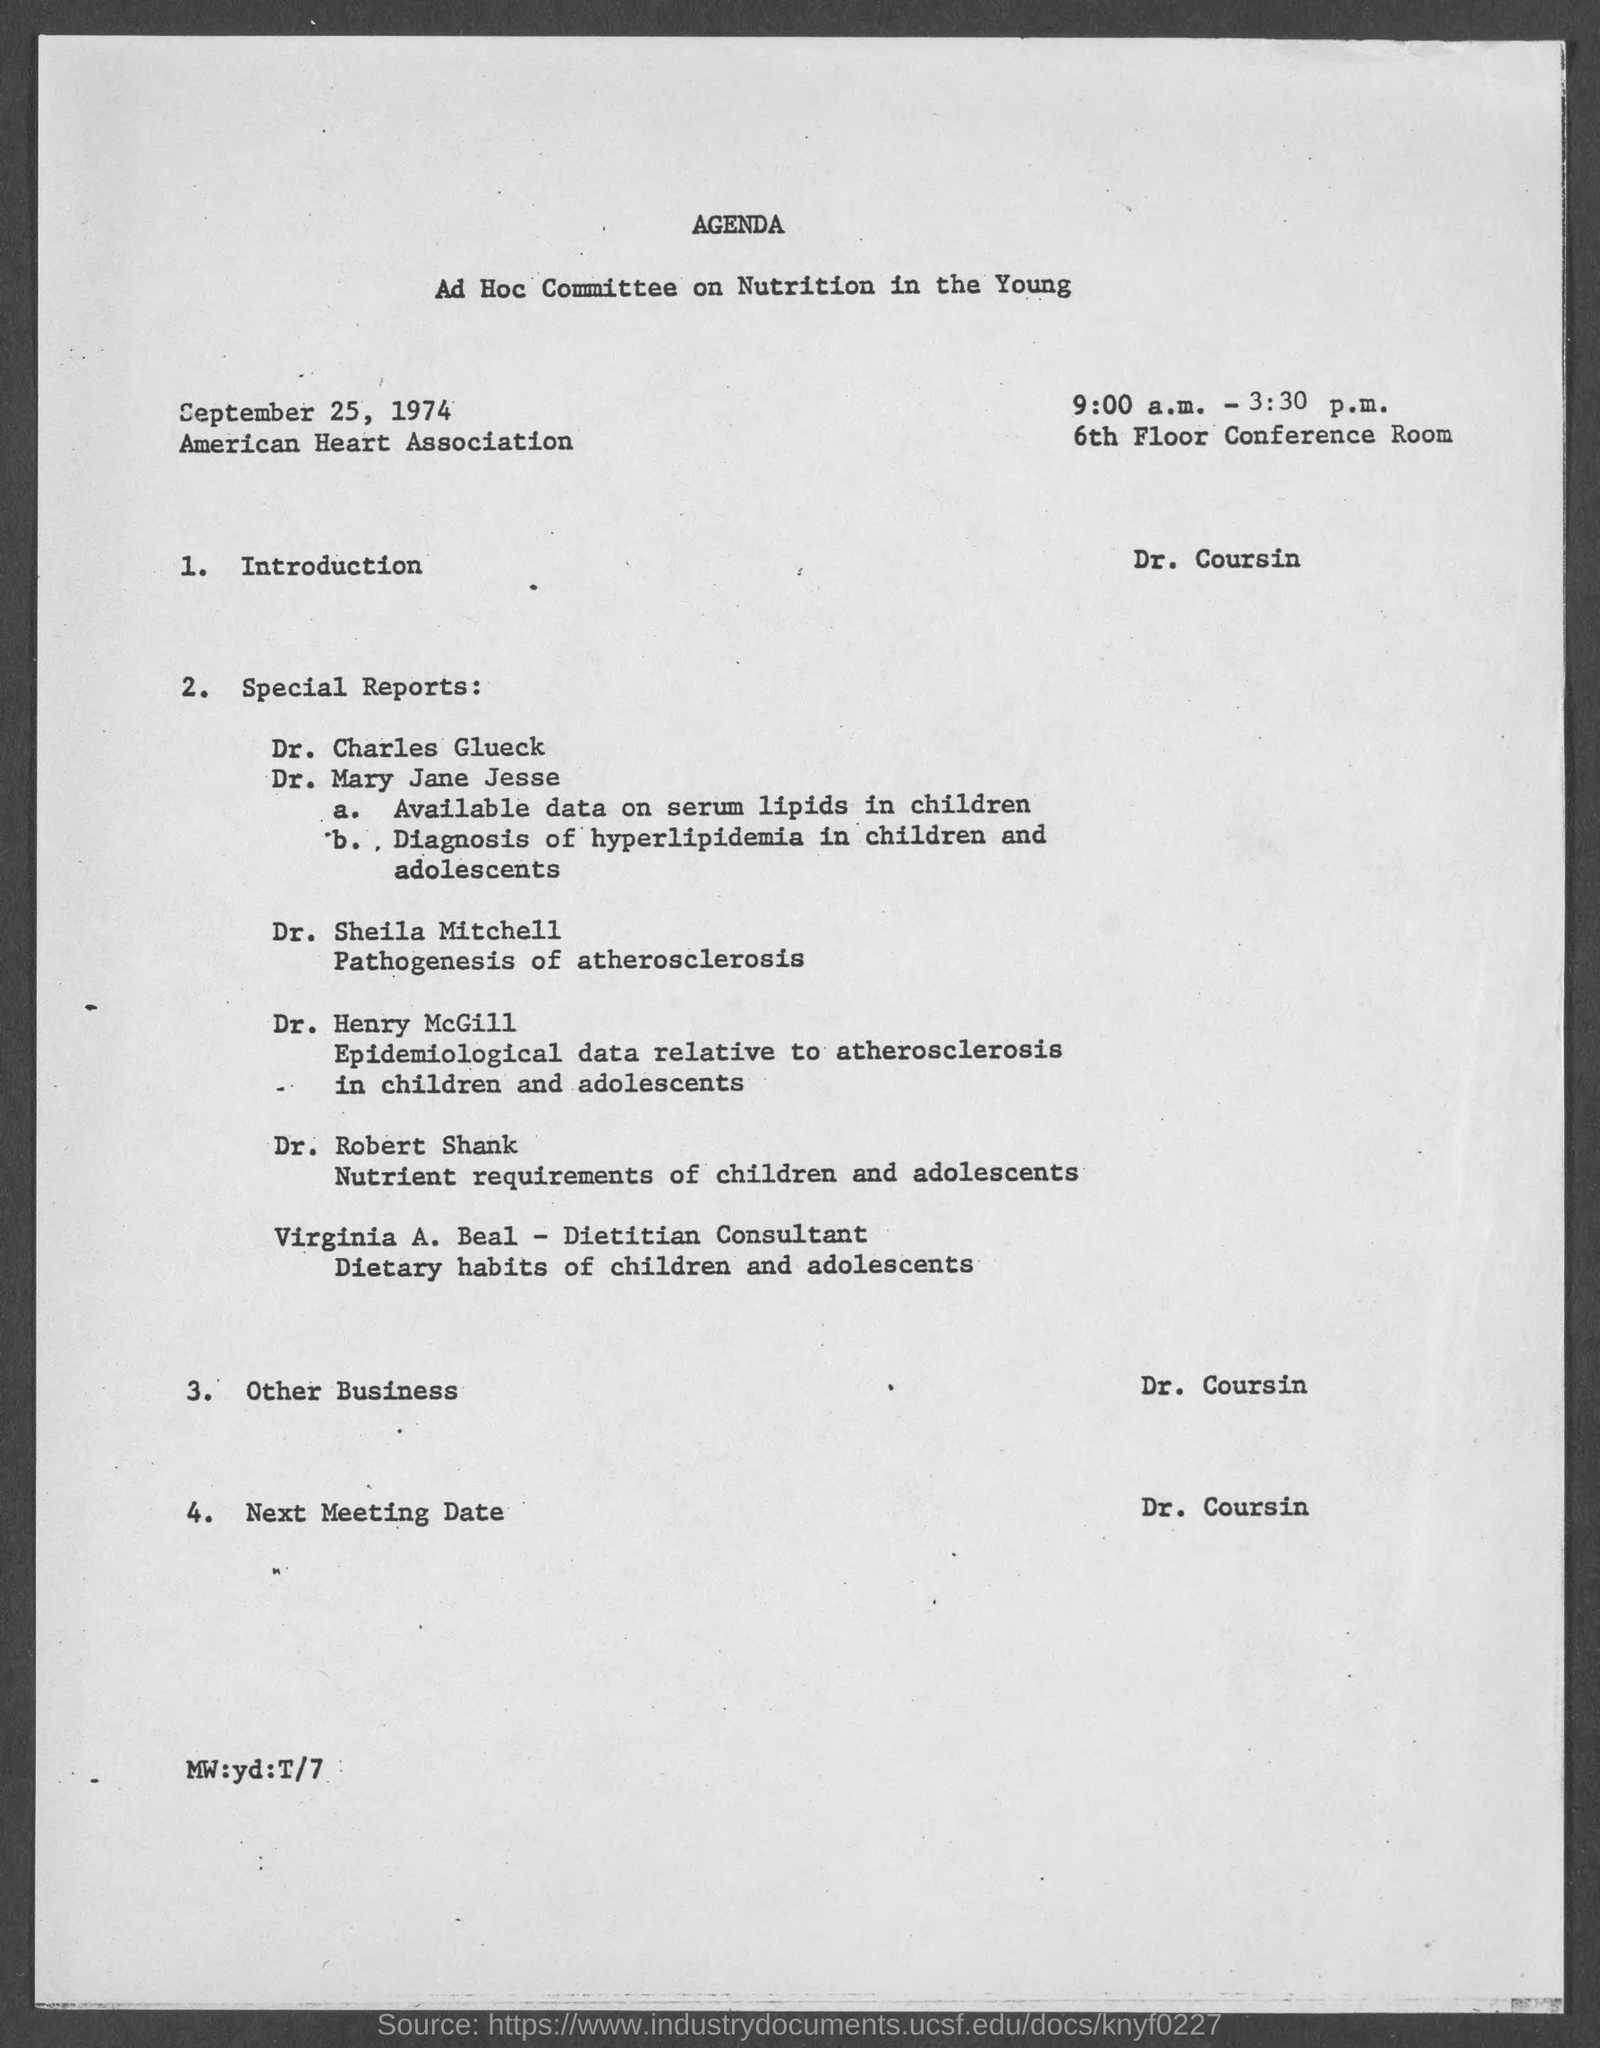When is the Ad Hoc Committee on Nutrition in the Young?
Your answer should be compact. September 25, 1974. What time  is the Ad Hoc Committee on Nutrition in the Young?
Provide a succinct answer. 9:00 a.m. - 3:30 p.m. Where is the Ad Hoc Committee on Nutrition in the Young?
Provide a succinct answer. American Heart Association 6th Floor Conference Room. Who is giving the Introduction?
Offer a terse response. Dr. Coursin. 